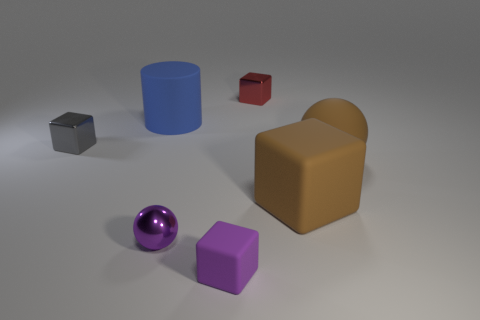Subtract all brown matte blocks. How many blocks are left? 3 Add 1 purple matte blocks. How many objects exist? 8 Subtract 3 blocks. How many blocks are left? 1 Subtract all cubes. How many objects are left? 3 Subtract all blue blocks. How many brown spheres are left? 1 Subtract all purple spheres. How many spheres are left? 1 Subtract all gray blocks. Subtract all cyan cylinders. How many blocks are left? 3 Add 3 big blue objects. How many big blue objects are left? 4 Add 2 tiny purple objects. How many tiny purple objects exist? 4 Subtract 0 blue spheres. How many objects are left? 7 